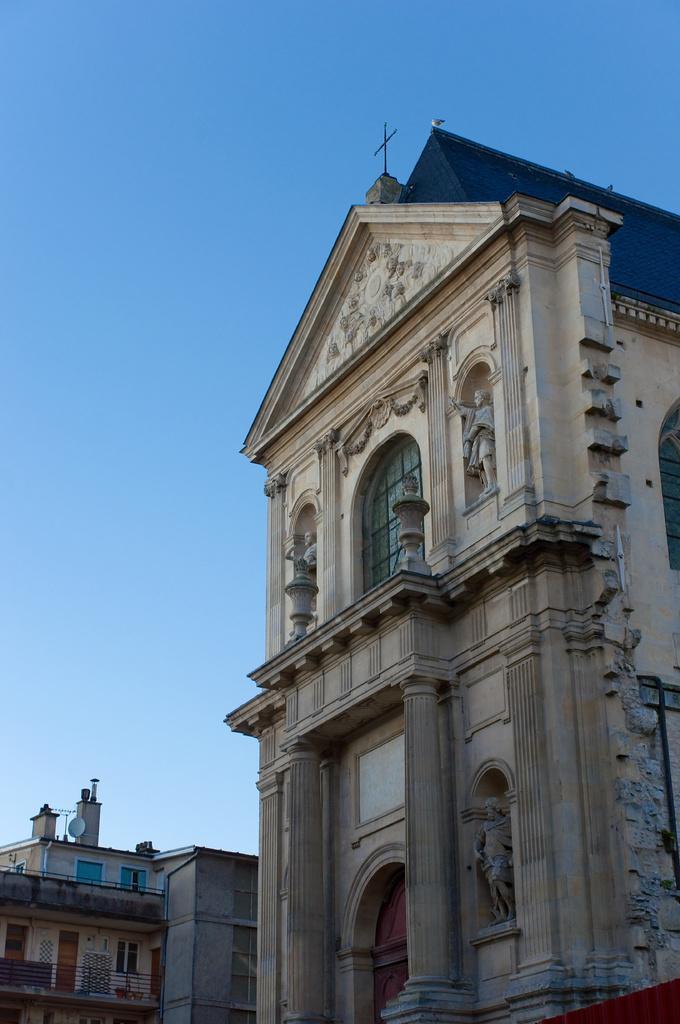Describe this image in one or two sentences. Here in this picture this building looks like a church with a cross symbol on the top of it. Here the sky is blue. 